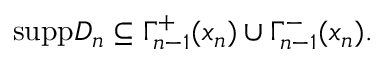Convert formula to latex. <formula><loc_0><loc_0><loc_500><loc_500>s u p p D _ { n } \subseteq \Gamma _ { n - 1 } ^ { + } ( x _ { n } ) \cup \Gamma _ { n - 1 } ^ { - } ( x _ { n } ) .</formula> 